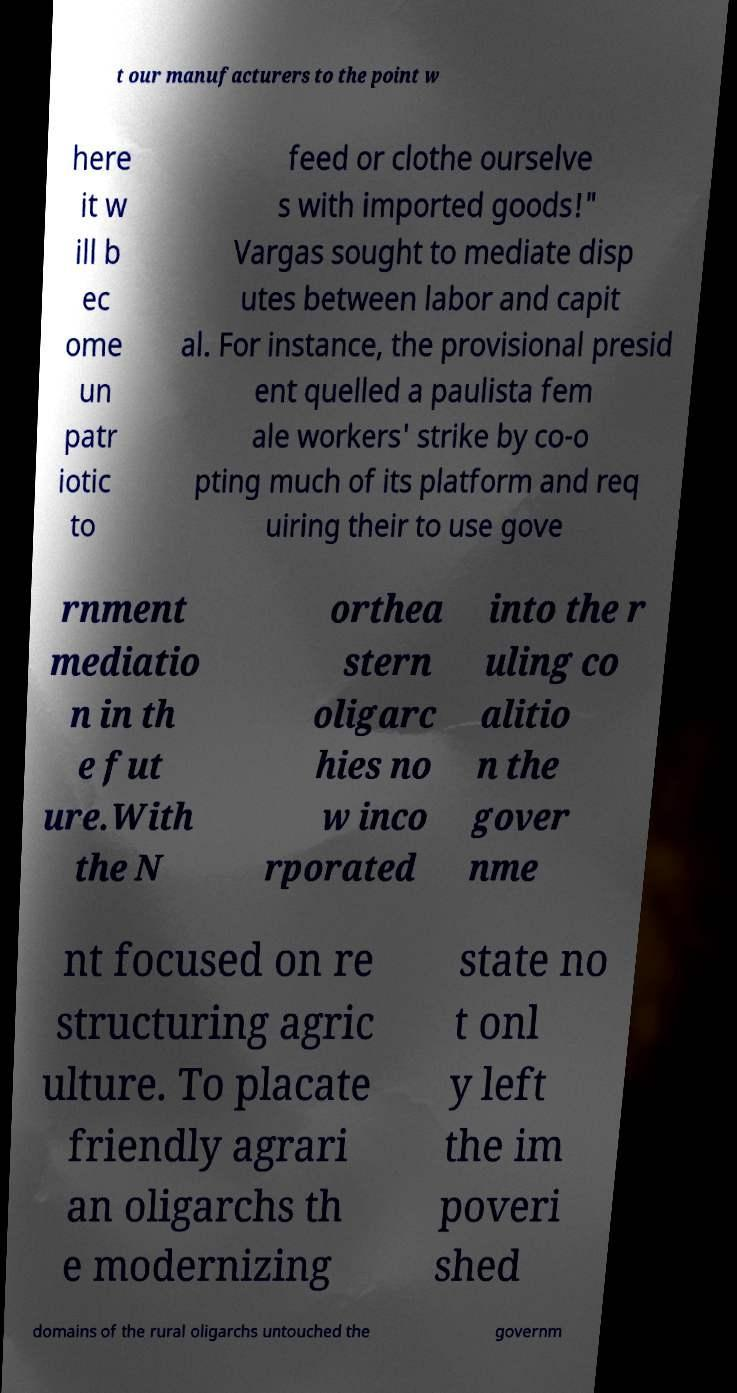Could you extract and type out the text from this image? t our manufacturers to the point w here it w ill b ec ome un patr iotic to feed or clothe ourselve s with imported goods!" Vargas sought to mediate disp utes between labor and capit al. For instance, the provisional presid ent quelled a paulista fem ale workers' strike by co-o pting much of its platform and req uiring their to use gove rnment mediatio n in th e fut ure.With the N orthea stern oligarc hies no w inco rporated into the r uling co alitio n the gover nme nt focused on re structuring agric ulture. To placate friendly agrari an oligarchs th e modernizing state no t onl y left the im poveri shed domains of the rural oligarchs untouched the governm 